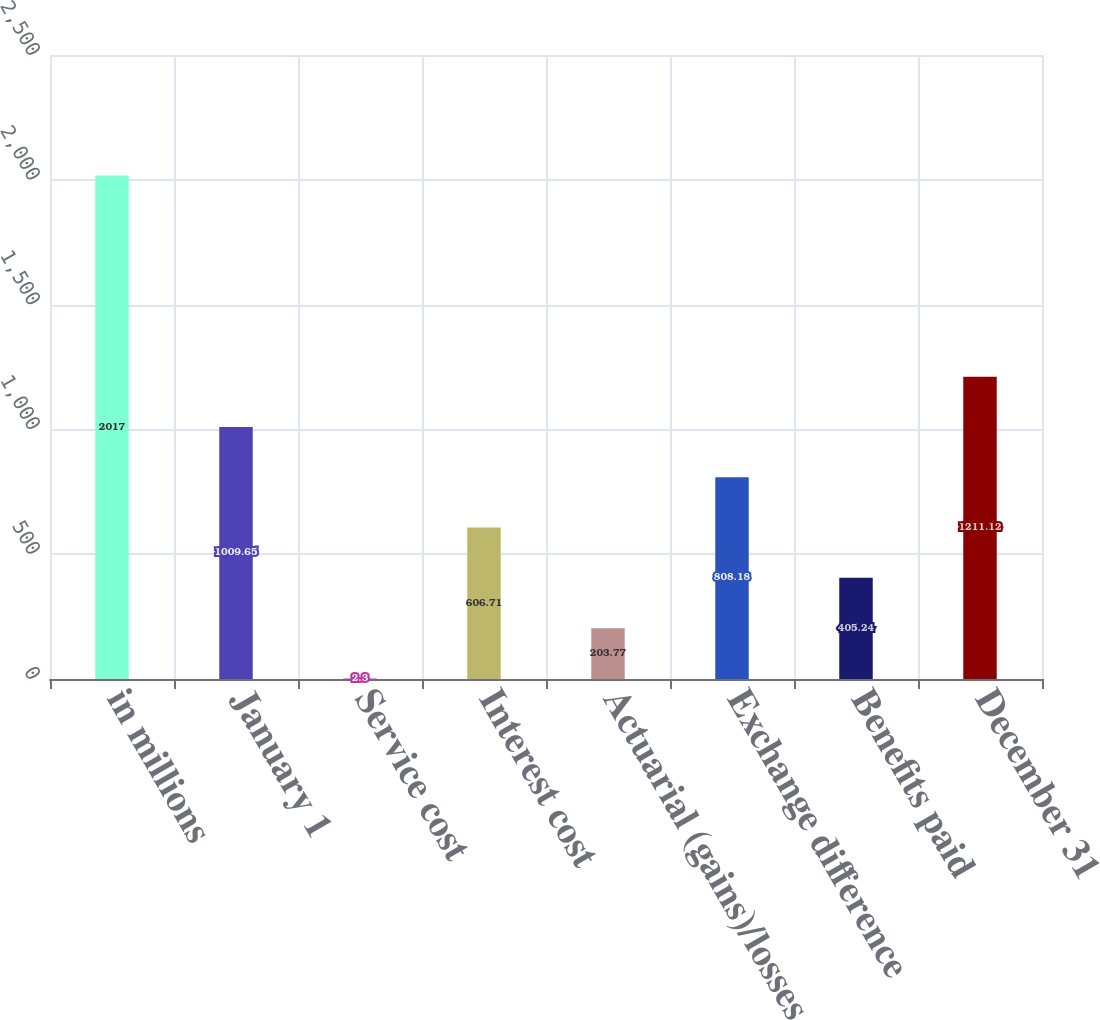Convert chart to OTSL. <chart><loc_0><loc_0><loc_500><loc_500><bar_chart><fcel>in millions<fcel>January 1<fcel>Service cost<fcel>Interest cost<fcel>Actuarial (gains)/losses<fcel>Exchange difference<fcel>Benefits paid<fcel>December 31<nl><fcel>2017<fcel>1009.65<fcel>2.3<fcel>606.71<fcel>203.77<fcel>808.18<fcel>405.24<fcel>1211.12<nl></chart> 